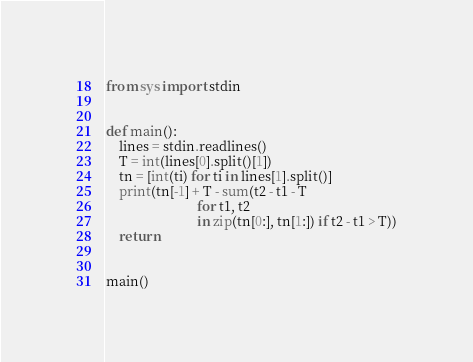<code> <loc_0><loc_0><loc_500><loc_500><_Python_>from sys import stdin


def main():
    lines = stdin.readlines()
    T = int(lines[0].split()[1])
    tn = [int(ti) for ti in lines[1].split()]
    print(tn[-1] + T - sum(t2 - t1 - T
                           for t1, t2
                           in zip(tn[0:], tn[1:]) if t2 - t1 > T))
    return


main()
</code> 